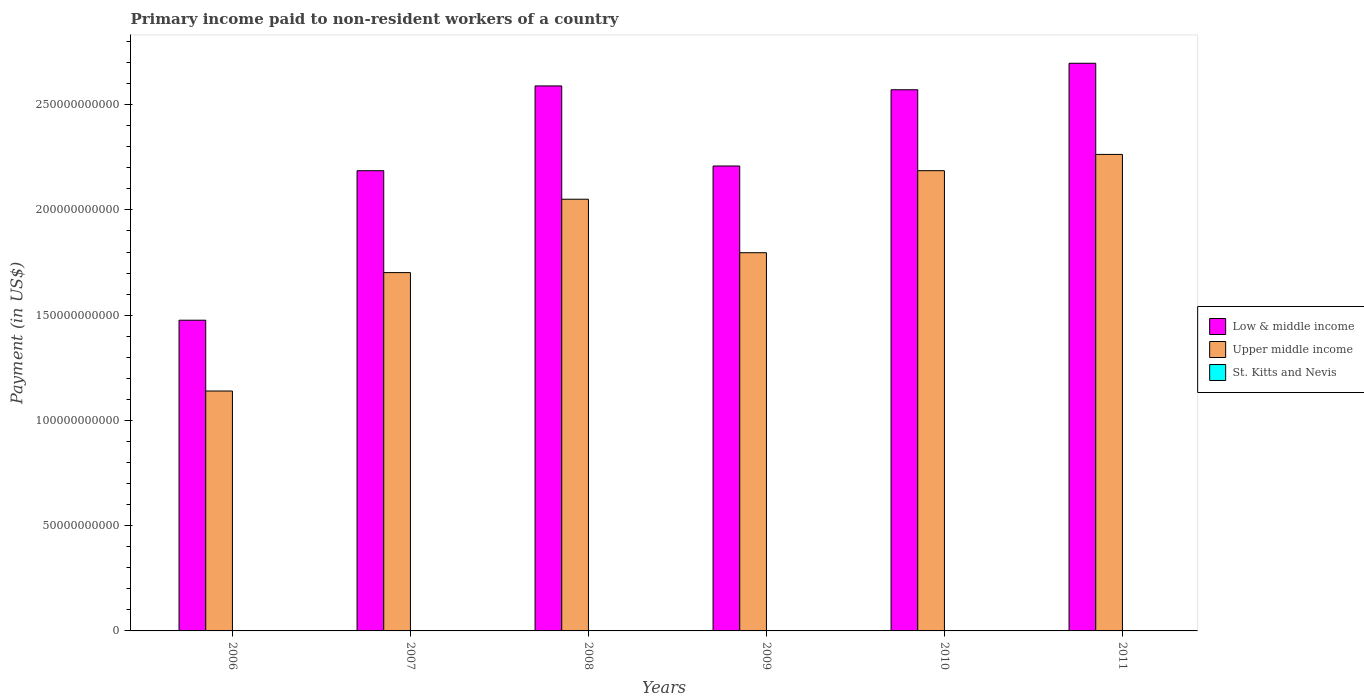How many different coloured bars are there?
Provide a succinct answer. 3. How many bars are there on the 6th tick from the right?
Your answer should be compact. 3. What is the amount paid to workers in St. Kitts and Nevis in 2011?
Provide a succinct answer. 6.38e+06. Across all years, what is the maximum amount paid to workers in St. Kitts and Nevis?
Offer a terse response. 1.47e+07. Across all years, what is the minimum amount paid to workers in St. Kitts and Nevis?
Ensure brevity in your answer.  6.38e+06. In which year was the amount paid to workers in St. Kitts and Nevis maximum?
Your answer should be compact. 2007. What is the total amount paid to workers in Upper middle income in the graph?
Keep it short and to the point. 1.11e+12. What is the difference between the amount paid to workers in Upper middle income in 2006 and that in 2007?
Ensure brevity in your answer.  -5.63e+1. What is the difference between the amount paid to workers in Low & middle income in 2011 and the amount paid to workers in Upper middle income in 2010?
Make the answer very short. 5.10e+1. What is the average amount paid to workers in St. Kitts and Nevis per year?
Your response must be concise. 1.04e+07. In the year 2008, what is the difference between the amount paid to workers in Upper middle income and amount paid to workers in Low & middle income?
Provide a short and direct response. -5.38e+1. In how many years, is the amount paid to workers in St. Kitts and Nevis greater than 110000000000 US$?
Offer a terse response. 0. What is the ratio of the amount paid to workers in Upper middle income in 2007 to that in 2008?
Keep it short and to the point. 0.83. Is the difference between the amount paid to workers in Upper middle income in 2007 and 2011 greater than the difference between the amount paid to workers in Low & middle income in 2007 and 2011?
Your response must be concise. No. What is the difference between the highest and the second highest amount paid to workers in Upper middle income?
Make the answer very short. 7.73e+09. What is the difference between the highest and the lowest amount paid to workers in St. Kitts and Nevis?
Your response must be concise. 8.36e+06. What does the 3rd bar from the left in 2009 represents?
Ensure brevity in your answer.  St. Kitts and Nevis. What does the 2nd bar from the right in 2008 represents?
Make the answer very short. Upper middle income. Is it the case that in every year, the sum of the amount paid to workers in Low & middle income and amount paid to workers in Upper middle income is greater than the amount paid to workers in St. Kitts and Nevis?
Give a very brief answer. Yes. How many bars are there?
Your answer should be very brief. 18. What is the difference between two consecutive major ticks on the Y-axis?
Offer a very short reply. 5.00e+1. Are the values on the major ticks of Y-axis written in scientific E-notation?
Your answer should be compact. No. Does the graph contain any zero values?
Offer a very short reply. No. Where does the legend appear in the graph?
Provide a succinct answer. Center right. How many legend labels are there?
Provide a succinct answer. 3. What is the title of the graph?
Your answer should be very brief. Primary income paid to non-resident workers of a country. What is the label or title of the X-axis?
Provide a short and direct response. Years. What is the label or title of the Y-axis?
Ensure brevity in your answer.  Payment (in US$). What is the Payment (in US$) in Low & middle income in 2006?
Your response must be concise. 1.48e+11. What is the Payment (in US$) of Upper middle income in 2006?
Your answer should be very brief. 1.14e+11. What is the Payment (in US$) in St. Kitts and Nevis in 2006?
Keep it short and to the point. 1.33e+07. What is the Payment (in US$) in Low & middle income in 2007?
Give a very brief answer. 2.19e+11. What is the Payment (in US$) of Upper middle income in 2007?
Keep it short and to the point. 1.70e+11. What is the Payment (in US$) of St. Kitts and Nevis in 2007?
Give a very brief answer. 1.47e+07. What is the Payment (in US$) in Low & middle income in 2008?
Ensure brevity in your answer.  2.59e+11. What is the Payment (in US$) in Upper middle income in 2008?
Your answer should be very brief. 2.05e+11. What is the Payment (in US$) in St. Kitts and Nevis in 2008?
Your answer should be compact. 1.00e+07. What is the Payment (in US$) in Low & middle income in 2009?
Your answer should be very brief. 2.21e+11. What is the Payment (in US$) in Upper middle income in 2009?
Give a very brief answer. 1.80e+11. What is the Payment (in US$) of St. Kitts and Nevis in 2009?
Offer a very short reply. 1.05e+07. What is the Payment (in US$) in Low & middle income in 2010?
Your answer should be compact. 2.57e+11. What is the Payment (in US$) of Upper middle income in 2010?
Your answer should be compact. 2.19e+11. What is the Payment (in US$) in St. Kitts and Nevis in 2010?
Ensure brevity in your answer.  7.71e+06. What is the Payment (in US$) of Low & middle income in 2011?
Your response must be concise. 2.70e+11. What is the Payment (in US$) of Upper middle income in 2011?
Keep it short and to the point. 2.26e+11. What is the Payment (in US$) in St. Kitts and Nevis in 2011?
Your answer should be very brief. 6.38e+06. Across all years, what is the maximum Payment (in US$) in Low & middle income?
Offer a terse response. 2.70e+11. Across all years, what is the maximum Payment (in US$) in Upper middle income?
Ensure brevity in your answer.  2.26e+11. Across all years, what is the maximum Payment (in US$) of St. Kitts and Nevis?
Give a very brief answer. 1.47e+07. Across all years, what is the minimum Payment (in US$) of Low & middle income?
Provide a short and direct response. 1.48e+11. Across all years, what is the minimum Payment (in US$) of Upper middle income?
Provide a succinct answer. 1.14e+11. Across all years, what is the minimum Payment (in US$) of St. Kitts and Nevis?
Provide a succinct answer. 6.38e+06. What is the total Payment (in US$) in Low & middle income in the graph?
Your response must be concise. 1.37e+12. What is the total Payment (in US$) of Upper middle income in the graph?
Your answer should be compact. 1.11e+12. What is the total Payment (in US$) of St. Kitts and Nevis in the graph?
Your answer should be compact. 6.26e+07. What is the difference between the Payment (in US$) of Low & middle income in 2006 and that in 2007?
Your response must be concise. -7.10e+1. What is the difference between the Payment (in US$) of Upper middle income in 2006 and that in 2007?
Make the answer very short. -5.63e+1. What is the difference between the Payment (in US$) in St. Kitts and Nevis in 2006 and that in 2007?
Provide a short and direct response. -1.46e+06. What is the difference between the Payment (in US$) in Low & middle income in 2006 and that in 2008?
Your response must be concise. -1.11e+11. What is the difference between the Payment (in US$) in Upper middle income in 2006 and that in 2008?
Your response must be concise. -9.11e+1. What is the difference between the Payment (in US$) of St. Kitts and Nevis in 2006 and that in 2008?
Ensure brevity in your answer.  3.26e+06. What is the difference between the Payment (in US$) of Low & middle income in 2006 and that in 2009?
Ensure brevity in your answer.  -7.33e+1. What is the difference between the Payment (in US$) of Upper middle income in 2006 and that in 2009?
Give a very brief answer. -6.57e+1. What is the difference between the Payment (in US$) in St. Kitts and Nevis in 2006 and that in 2009?
Your response must be concise. 2.79e+06. What is the difference between the Payment (in US$) of Low & middle income in 2006 and that in 2010?
Offer a terse response. -1.09e+11. What is the difference between the Payment (in US$) of Upper middle income in 2006 and that in 2010?
Ensure brevity in your answer.  -1.05e+11. What is the difference between the Payment (in US$) in St. Kitts and Nevis in 2006 and that in 2010?
Give a very brief answer. 5.57e+06. What is the difference between the Payment (in US$) of Low & middle income in 2006 and that in 2011?
Ensure brevity in your answer.  -1.22e+11. What is the difference between the Payment (in US$) in Upper middle income in 2006 and that in 2011?
Your answer should be very brief. -1.12e+11. What is the difference between the Payment (in US$) in St. Kitts and Nevis in 2006 and that in 2011?
Your answer should be very brief. 6.90e+06. What is the difference between the Payment (in US$) in Low & middle income in 2007 and that in 2008?
Make the answer very short. -4.03e+1. What is the difference between the Payment (in US$) of Upper middle income in 2007 and that in 2008?
Your answer should be compact. -3.49e+1. What is the difference between the Payment (in US$) in St. Kitts and Nevis in 2007 and that in 2008?
Your answer should be very brief. 4.72e+06. What is the difference between the Payment (in US$) of Low & middle income in 2007 and that in 2009?
Ensure brevity in your answer.  -2.24e+09. What is the difference between the Payment (in US$) in Upper middle income in 2007 and that in 2009?
Your answer should be very brief. -9.45e+09. What is the difference between the Payment (in US$) of St. Kitts and Nevis in 2007 and that in 2009?
Give a very brief answer. 4.25e+06. What is the difference between the Payment (in US$) of Low & middle income in 2007 and that in 2010?
Your answer should be very brief. -3.85e+1. What is the difference between the Payment (in US$) in Upper middle income in 2007 and that in 2010?
Offer a terse response. -4.84e+1. What is the difference between the Payment (in US$) of St. Kitts and Nevis in 2007 and that in 2010?
Your answer should be very brief. 7.03e+06. What is the difference between the Payment (in US$) of Low & middle income in 2007 and that in 2011?
Make the answer very short. -5.10e+1. What is the difference between the Payment (in US$) in Upper middle income in 2007 and that in 2011?
Provide a short and direct response. -5.61e+1. What is the difference between the Payment (in US$) of St. Kitts and Nevis in 2007 and that in 2011?
Make the answer very short. 8.36e+06. What is the difference between the Payment (in US$) in Low & middle income in 2008 and that in 2009?
Make the answer very short. 3.80e+1. What is the difference between the Payment (in US$) of Upper middle income in 2008 and that in 2009?
Ensure brevity in your answer.  2.54e+1. What is the difference between the Payment (in US$) in St. Kitts and Nevis in 2008 and that in 2009?
Offer a terse response. -4.72e+05. What is the difference between the Payment (in US$) of Low & middle income in 2008 and that in 2010?
Provide a succinct answer. 1.82e+09. What is the difference between the Payment (in US$) of Upper middle income in 2008 and that in 2010?
Give a very brief answer. -1.36e+1. What is the difference between the Payment (in US$) in St. Kitts and Nevis in 2008 and that in 2010?
Ensure brevity in your answer.  2.31e+06. What is the difference between the Payment (in US$) in Low & middle income in 2008 and that in 2011?
Offer a very short reply. -1.08e+1. What is the difference between the Payment (in US$) in Upper middle income in 2008 and that in 2011?
Give a very brief answer. -2.13e+1. What is the difference between the Payment (in US$) in St. Kitts and Nevis in 2008 and that in 2011?
Your answer should be very brief. 3.64e+06. What is the difference between the Payment (in US$) in Low & middle income in 2009 and that in 2010?
Your response must be concise. -3.62e+1. What is the difference between the Payment (in US$) of Upper middle income in 2009 and that in 2010?
Provide a succinct answer. -3.90e+1. What is the difference between the Payment (in US$) of St. Kitts and Nevis in 2009 and that in 2010?
Give a very brief answer. 2.78e+06. What is the difference between the Payment (in US$) in Low & middle income in 2009 and that in 2011?
Your response must be concise. -4.88e+1. What is the difference between the Payment (in US$) of Upper middle income in 2009 and that in 2011?
Your response must be concise. -4.67e+1. What is the difference between the Payment (in US$) of St. Kitts and Nevis in 2009 and that in 2011?
Offer a very short reply. 4.11e+06. What is the difference between the Payment (in US$) in Low & middle income in 2010 and that in 2011?
Make the answer very short. -1.26e+1. What is the difference between the Payment (in US$) of Upper middle income in 2010 and that in 2011?
Your answer should be compact. -7.73e+09. What is the difference between the Payment (in US$) in St. Kitts and Nevis in 2010 and that in 2011?
Make the answer very short. 1.33e+06. What is the difference between the Payment (in US$) in Low & middle income in 2006 and the Payment (in US$) in Upper middle income in 2007?
Make the answer very short. -2.26e+1. What is the difference between the Payment (in US$) in Low & middle income in 2006 and the Payment (in US$) in St. Kitts and Nevis in 2007?
Your response must be concise. 1.48e+11. What is the difference between the Payment (in US$) in Upper middle income in 2006 and the Payment (in US$) in St. Kitts and Nevis in 2007?
Your answer should be compact. 1.14e+11. What is the difference between the Payment (in US$) in Low & middle income in 2006 and the Payment (in US$) in Upper middle income in 2008?
Your answer should be compact. -5.75e+1. What is the difference between the Payment (in US$) of Low & middle income in 2006 and the Payment (in US$) of St. Kitts and Nevis in 2008?
Your answer should be compact. 1.48e+11. What is the difference between the Payment (in US$) in Upper middle income in 2006 and the Payment (in US$) in St. Kitts and Nevis in 2008?
Make the answer very short. 1.14e+11. What is the difference between the Payment (in US$) of Low & middle income in 2006 and the Payment (in US$) of Upper middle income in 2009?
Your answer should be compact. -3.21e+1. What is the difference between the Payment (in US$) of Low & middle income in 2006 and the Payment (in US$) of St. Kitts and Nevis in 2009?
Provide a short and direct response. 1.48e+11. What is the difference between the Payment (in US$) of Upper middle income in 2006 and the Payment (in US$) of St. Kitts and Nevis in 2009?
Your answer should be compact. 1.14e+11. What is the difference between the Payment (in US$) in Low & middle income in 2006 and the Payment (in US$) in Upper middle income in 2010?
Ensure brevity in your answer.  -7.10e+1. What is the difference between the Payment (in US$) in Low & middle income in 2006 and the Payment (in US$) in St. Kitts and Nevis in 2010?
Your answer should be very brief. 1.48e+11. What is the difference between the Payment (in US$) in Upper middle income in 2006 and the Payment (in US$) in St. Kitts and Nevis in 2010?
Provide a short and direct response. 1.14e+11. What is the difference between the Payment (in US$) in Low & middle income in 2006 and the Payment (in US$) in Upper middle income in 2011?
Offer a terse response. -7.88e+1. What is the difference between the Payment (in US$) in Low & middle income in 2006 and the Payment (in US$) in St. Kitts and Nevis in 2011?
Keep it short and to the point. 1.48e+11. What is the difference between the Payment (in US$) in Upper middle income in 2006 and the Payment (in US$) in St. Kitts and Nevis in 2011?
Give a very brief answer. 1.14e+11. What is the difference between the Payment (in US$) in Low & middle income in 2007 and the Payment (in US$) in Upper middle income in 2008?
Provide a short and direct response. 1.35e+1. What is the difference between the Payment (in US$) in Low & middle income in 2007 and the Payment (in US$) in St. Kitts and Nevis in 2008?
Offer a very short reply. 2.19e+11. What is the difference between the Payment (in US$) in Upper middle income in 2007 and the Payment (in US$) in St. Kitts and Nevis in 2008?
Your response must be concise. 1.70e+11. What is the difference between the Payment (in US$) of Low & middle income in 2007 and the Payment (in US$) of Upper middle income in 2009?
Your response must be concise. 3.90e+1. What is the difference between the Payment (in US$) in Low & middle income in 2007 and the Payment (in US$) in St. Kitts and Nevis in 2009?
Your answer should be very brief. 2.19e+11. What is the difference between the Payment (in US$) of Upper middle income in 2007 and the Payment (in US$) of St. Kitts and Nevis in 2009?
Keep it short and to the point. 1.70e+11. What is the difference between the Payment (in US$) in Low & middle income in 2007 and the Payment (in US$) in Upper middle income in 2010?
Your response must be concise. -1.18e+07. What is the difference between the Payment (in US$) of Low & middle income in 2007 and the Payment (in US$) of St. Kitts and Nevis in 2010?
Give a very brief answer. 2.19e+11. What is the difference between the Payment (in US$) in Upper middle income in 2007 and the Payment (in US$) in St. Kitts and Nevis in 2010?
Your response must be concise. 1.70e+11. What is the difference between the Payment (in US$) of Low & middle income in 2007 and the Payment (in US$) of Upper middle income in 2011?
Offer a terse response. -7.74e+09. What is the difference between the Payment (in US$) of Low & middle income in 2007 and the Payment (in US$) of St. Kitts and Nevis in 2011?
Offer a terse response. 2.19e+11. What is the difference between the Payment (in US$) in Upper middle income in 2007 and the Payment (in US$) in St. Kitts and Nevis in 2011?
Provide a succinct answer. 1.70e+11. What is the difference between the Payment (in US$) in Low & middle income in 2008 and the Payment (in US$) in Upper middle income in 2009?
Provide a short and direct response. 7.92e+1. What is the difference between the Payment (in US$) of Low & middle income in 2008 and the Payment (in US$) of St. Kitts and Nevis in 2009?
Provide a short and direct response. 2.59e+11. What is the difference between the Payment (in US$) in Upper middle income in 2008 and the Payment (in US$) in St. Kitts and Nevis in 2009?
Offer a very short reply. 2.05e+11. What is the difference between the Payment (in US$) in Low & middle income in 2008 and the Payment (in US$) in Upper middle income in 2010?
Keep it short and to the point. 4.03e+1. What is the difference between the Payment (in US$) of Low & middle income in 2008 and the Payment (in US$) of St. Kitts and Nevis in 2010?
Give a very brief answer. 2.59e+11. What is the difference between the Payment (in US$) of Upper middle income in 2008 and the Payment (in US$) of St. Kitts and Nevis in 2010?
Ensure brevity in your answer.  2.05e+11. What is the difference between the Payment (in US$) in Low & middle income in 2008 and the Payment (in US$) in Upper middle income in 2011?
Keep it short and to the point. 3.25e+1. What is the difference between the Payment (in US$) in Low & middle income in 2008 and the Payment (in US$) in St. Kitts and Nevis in 2011?
Provide a short and direct response. 2.59e+11. What is the difference between the Payment (in US$) of Upper middle income in 2008 and the Payment (in US$) of St. Kitts and Nevis in 2011?
Provide a succinct answer. 2.05e+11. What is the difference between the Payment (in US$) in Low & middle income in 2009 and the Payment (in US$) in Upper middle income in 2010?
Your answer should be very brief. 2.22e+09. What is the difference between the Payment (in US$) in Low & middle income in 2009 and the Payment (in US$) in St. Kitts and Nevis in 2010?
Ensure brevity in your answer.  2.21e+11. What is the difference between the Payment (in US$) in Upper middle income in 2009 and the Payment (in US$) in St. Kitts and Nevis in 2010?
Offer a terse response. 1.80e+11. What is the difference between the Payment (in US$) of Low & middle income in 2009 and the Payment (in US$) of Upper middle income in 2011?
Your answer should be compact. -5.50e+09. What is the difference between the Payment (in US$) in Low & middle income in 2009 and the Payment (in US$) in St. Kitts and Nevis in 2011?
Offer a very short reply. 2.21e+11. What is the difference between the Payment (in US$) in Upper middle income in 2009 and the Payment (in US$) in St. Kitts and Nevis in 2011?
Keep it short and to the point. 1.80e+11. What is the difference between the Payment (in US$) of Low & middle income in 2010 and the Payment (in US$) of Upper middle income in 2011?
Ensure brevity in your answer.  3.07e+1. What is the difference between the Payment (in US$) in Low & middle income in 2010 and the Payment (in US$) in St. Kitts and Nevis in 2011?
Keep it short and to the point. 2.57e+11. What is the difference between the Payment (in US$) of Upper middle income in 2010 and the Payment (in US$) of St. Kitts and Nevis in 2011?
Make the answer very short. 2.19e+11. What is the average Payment (in US$) in Low & middle income per year?
Your answer should be compact. 2.29e+11. What is the average Payment (in US$) of Upper middle income per year?
Ensure brevity in your answer.  1.86e+11. What is the average Payment (in US$) of St. Kitts and Nevis per year?
Provide a short and direct response. 1.04e+07. In the year 2006, what is the difference between the Payment (in US$) of Low & middle income and Payment (in US$) of Upper middle income?
Provide a succinct answer. 3.36e+1. In the year 2006, what is the difference between the Payment (in US$) in Low & middle income and Payment (in US$) in St. Kitts and Nevis?
Offer a very short reply. 1.48e+11. In the year 2006, what is the difference between the Payment (in US$) in Upper middle income and Payment (in US$) in St. Kitts and Nevis?
Keep it short and to the point. 1.14e+11. In the year 2007, what is the difference between the Payment (in US$) in Low & middle income and Payment (in US$) in Upper middle income?
Keep it short and to the point. 4.84e+1. In the year 2007, what is the difference between the Payment (in US$) of Low & middle income and Payment (in US$) of St. Kitts and Nevis?
Give a very brief answer. 2.19e+11. In the year 2007, what is the difference between the Payment (in US$) in Upper middle income and Payment (in US$) in St. Kitts and Nevis?
Your response must be concise. 1.70e+11. In the year 2008, what is the difference between the Payment (in US$) in Low & middle income and Payment (in US$) in Upper middle income?
Keep it short and to the point. 5.38e+1. In the year 2008, what is the difference between the Payment (in US$) in Low & middle income and Payment (in US$) in St. Kitts and Nevis?
Your response must be concise. 2.59e+11. In the year 2008, what is the difference between the Payment (in US$) of Upper middle income and Payment (in US$) of St. Kitts and Nevis?
Give a very brief answer. 2.05e+11. In the year 2009, what is the difference between the Payment (in US$) of Low & middle income and Payment (in US$) of Upper middle income?
Your answer should be very brief. 4.12e+1. In the year 2009, what is the difference between the Payment (in US$) of Low & middle income and Payment (in US$) of St. Kitts and Nevis?
Make the answer very short. 2.21e+11. In the year 2009, what is the difference between the Payment (in US$) in Upper middle income and Payment (in US$) in St. Kitts and Nevis?
Offer a very short reply. 1.80e+11. In the year 2010, what is the difference between the Payment (in US$) in Low & middle income and Payment (in US$) in Upper middle income?
Provide a succinct answer. 3.84e+1. In the year 2010, what is the difference between the Payment (in US$) of Low & middle income and Payment (in US$) of St. Kitts and Nevis?
Your answer should be very brief. 2.57e+11. In the year 2010, what is the difference between the Payment (in US$) of Upper middle income and Payment (in US$) of St. Kitts and Nevis?
Your answer should be very brief. 2.19e+11. In the year 2011, what is the difference between the Payment (in US$) in Low & middle income and Payment (in US$) in Upper middle income?
Your response must be concise. 4.33e+1. In the year 2011, what is the difference between the Payment (in US$) of Low & middle income and Payment (in US$) of St. Kitts and Nevis?
Your response must be concise. 2.70e+11. In the year 2011, what is the difference between the Payment (in US$) of Upper middle income and Payment (in US$) of St. Kitts and Nevis?
Your answer should be very brief. 2.26e+11. What is the ratio of the Payment (in US$) of Low & middle income in 2006 to that in 2007?
Ensure brevity in your answer.  0.68. What is the ratio of the Payment (in US$) in Upper middle income in 2006 to that in 2007?
Ensure brevity in your answer.  0.67. What is the ratio of the Payment (in US$) of St. Kitts and Nevis in 2006 to that in 2007?
Provide a short and direct response. 0.9. What is the ratio of the Payment (in US$) in Low & middle income in 2006 to that in 2008?
Ensure brevity in your answer.  0.57. What is the ratio of the Payment (in US$) of Upper middle income in 2006 to that in 2008?
Offer a very short reply. 0.56. What is the ratio of the Payment (in US$) in St. Kitts and Nevis in 2006 to that in 2008?
Provide a short and direct response. 1.33. What is the ratio of the Payment (in US$) in Low & middle income in 2006 to that in 2009?
Keep it short and to the point. 0.67. What is the ratio of the Payment (in US$) in Upper middle income in 2006 to that in 2009?
Your response must be concise. 0.63. What is the ratio of the Payment (in US$) of St. Kitts and Nevis in 2006 to that in 2009?
Ensure brevity in your answer.  1.27. What is the ratio of the Payment (in US$) in Low & middle income in 2006 to that in 2010?
Ensure brevity in your answer.  0.57. What is the ratio of the Payment (in US$) of Upper middle income in 2006 to that in 2010?
Make the answer very short. 0.52. What is the ratio of the Payment (in US$) in St. Kitts and Nevis in 2006 to that in 2010?
Offer a terse response. 1.72. What is the ratio of the Payment (in US$) of Low & middle income in 2006 to that in 2011?
Ensure brevity in your answer.  0.55. What is the ratio of the Payment (in US$) of Upper middle income in 2006 to that in 2011?
Make the answer very short. 0.5. What is the ratio of the Payment (in US$) in St. Kitts and Nevis in 2006 to that in 2011?
Your response must be concise. 2.08. What is the ratio of the Payment (in US$) in Low & middle income in 2007 to that in 2008?
Your response must be concise. 0.84. What is the ratio of the Payment (in US$) of Upper middle income in 2007 to that in 2008?
Provide a succinct answer. 0.83. What is the ratio of the Payment (in US$) of St. Kitts and Nevis in 2007 to that in 2008?
Provide a short and direct response. 1.47. What is the ratio of the Payment (in US$) in St. Kitts and Nevis in 2007 to that in 2009?
Provide a short and direct response. 1.41. What is the ratio of the Payment (in US$) in Low & middle income in 2007 to that in 2010?
Give a very brief answer. 0.85. What is the ratio of the Payment (in US$) of Upper middle income in 2007 to that in 2010?
Offer a very short reply. 0.78. What is the ratio of the Payment (in US$) in St. Kitts and Nevis in 2007 to that in 2010?
Your answer should be very brief. 1.91. What is the ratio of the Payment (in US$) in Low & middle income in 2007 to that in 2011?
Make the answer very short. 0.81. What is the ratio of the Payment (in US$) of Upper middle income in 2007 to that in 2011?
Offer a terse response. 0.75. What is the ratio of the Payment (in US$) of St. Kitts and Nevis in 2007 to that in 2011?
Your response must be concise. 2.31. What is the ratio of the Payment (in US$) of Low & middle income in 2008 to that in 2009?
Your response must be concise. 1.17. What is the ratio of the Payment (in US$) in Upper middle income in 2008 to that in 2009?
Your response must be concise. 1.14. What is the ratio of the Payment (in US$) of St. Kitts and Nevis in 2008 to that in 2009?
Your response must be concise. 0.95. What is the ratio of the Payment (in US$) in Low & middle income in 2008 to that in 2010?
Offer a very short reply. 1.01. What is the ratio of the Payment (in US$) in Upper middle income in 2008 to that in 2010?
Offer a very short reply. 0.94. What is the ratio of the Payment (in US$) of St. Kitts and Nevis in 2008 to that in 2010?
Keep it short and to the point. 1.3. What is the ratio of the Payment (in US$) of Low & middle income in 2008 to that in 2011?
Offer a very short reply. 0.96. What is the ratio of the Payment (in US$) of Upper middle income in 2008 to that in 2011?
Offer a terse response. 0.91. What is the ratio of the Payment (in US$) of St. Kitts and Nevis in 2008 to that in 2011?
Your response must be concise. 1.57. What is the ratio of the Payment (in US$) of Low & middle income in 2009 to that in 2010?
Your answer should be very brief. 0.86. What is the ratio of the Payment (in US$) of Upper middle income in 2009 to that in 2010?
Your answer should be very brief. 0.82. What is the ratio of the Payment (in US$) in St. Kitts and Nevis in 2009 to that in 2010?
Ensure brevity in your answer.  1.36. What is the ratio of the Payment (in US$) of Low & middle income in 2009 to that in 2011?
Offer a terse response. 0.82. What is the ratio of the Payment (in US$) in Upper middle income in 2009 to that in 2011?
Your answer should be very brief. 0.79. What is the ratio of the Payment (in US$) of St. Kitts and Nevis in 2009 to that in 2011?
Provide a succinct answer. 1.64. What is the ratio of the Payment (in US$) of Low & middle income in 2010 to that in 2011?
Make the answer very short. 0.95. What is the ratio of the Payment (in US$) of Upper middle income in 2010 to that in 2011?
Ensure brevity in your answer.  0.97. What is the ratio of the Payment (in US$) of St. Kitts and Nevis in 2010 to that in 2011?
Your answer should be compact. 1.21. What is the difference between the highest and the second highest Payment (in US$) of Low & middle income?
Offer a terse response. 1.08e+1. What is the difference between the highest and the second highest Payment (in US$) in Upper middle income?
Your answer should be compact. 7.73e+09. What is the difference between the highest and the second highest Payment (in US$) in St. Kitts and Nevis?
Your response must be concise. 1.46e+06. What is the difference between the highest and the lowest Payment (in US$) of Low & middle income?
Your answer should be very brief. 1.22e+11. What is the difference between the highest and the lowest Payment (in US$) in Upper middle income?
Your response must be concise. 1.12e+11. What is the difference between the highest and the lowest Payment (in US$) of St. Kitts and Nevis?
Your response must be concise. 8.36e+06. 